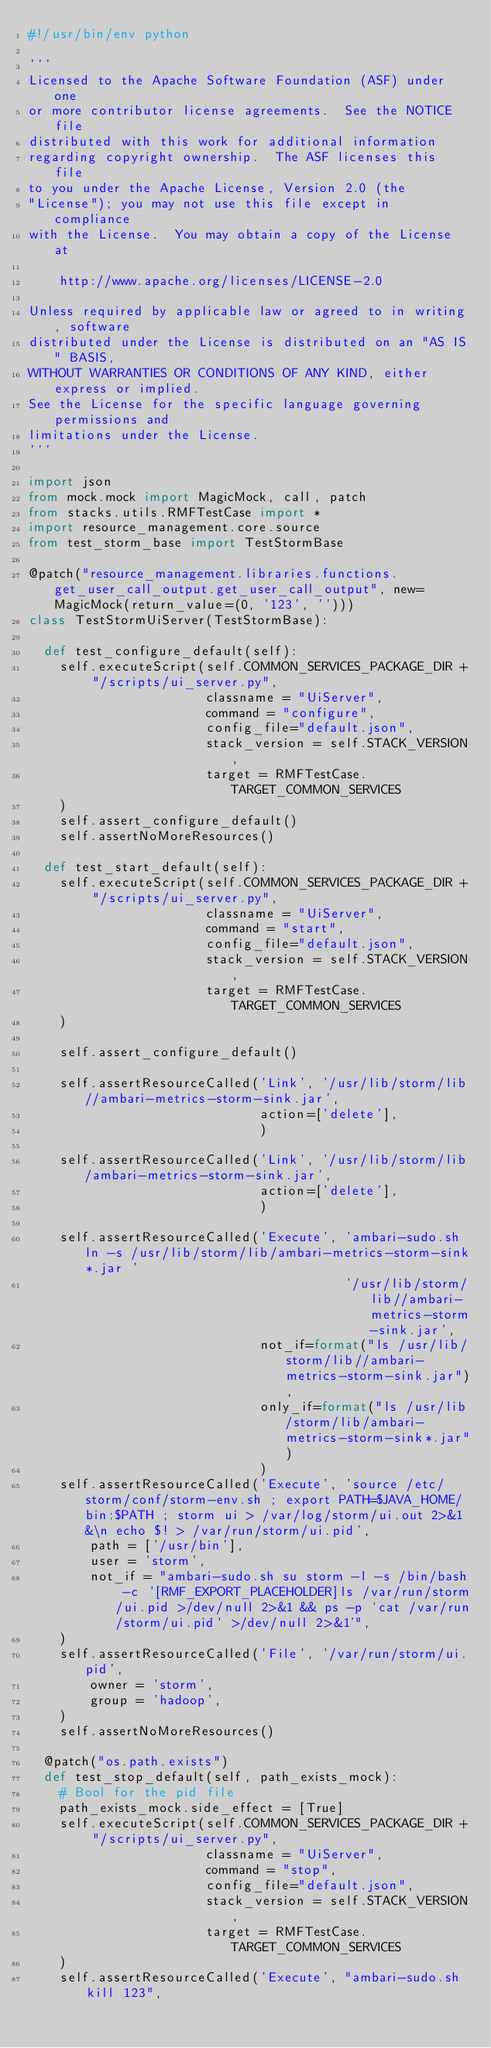Convert code to text. <code><loc_0><loc_0><loc_500><loc_500><_Python_>#!/usr/bin/env python

'''
Licensed to the Apache Software Foundation (ASF) under one
or more contributor license agreements.  See the NOTICE file
distributed with this work for additional information
regarding copyright ownership.  The ASF licenses this file
to you under the Apache License, Version 2.0 (the
"License"); you may not use this file except in compliance
with the License.  You may obtain a copy of the License at

    http://www.apache.org/licenses/LICENSE-2.0

Unless required by applicable law or agreed to in writing, software
distributed under the License is distributed on an "AS IS" BASIS,
WITHOUT WARRANTIES OR CONDITIONS OF ANY KIND, either express or implied.
See the License for the specific language governing permissions and
limitations under the License.
'''

import json
from mock.mock import MagicMock, call, patch
from stacks.utils.RMFTestCase import *
import resource_management.core.source
from test_storm_base import TestStormBase

@patch("resource_management.libraries.functions.get_user_call_output.get_user_call_output", new=MagicMock(return_value=(0, '123', '')))
class TestStormUiServer(TestStormBase):

  def test_configure_default(self):
    self.executeScript(self.COMMON_SERVICES_PACKAGE_DIR + "/scripts/ui_server.py",
                       classname = "UiServer",
                       command = "configure",
                       config_file="default.json",
                       stack_version = self.STACK_VERSION,
                       target = RMFTestCase.TARGET_COMMON_SERVICES
    )
    self.assert_configure_default()
    self.assertNoMoreResources()

  def test_start_default(self):
    self.executeScript(self.COMMON_SERVICES_PACKAGE_DIR + "/scripts/ui_server.py",
                       classname = "UiServer",
                       command = "start",
                       config_file="default.json",
                       stack_version = self.STACK_VERSION,
                       target = RMFTestCase.TARGET_COMMON_SERVICES
    )

    self.assert_configure_default()

    self.assertResourceCalled('Link', '/usr/lib/storm/lib//ambari-metrics-storm-sink.jar',
                              action=['delete'],
                              )

    self.assertResourceCalled('Link', '/usr/lib/storm/lib/ambari-metrics-storm-sink.jar',
                              action=['delete'],
                              )

    self.assertResourceCalled('Execute', 'ambari-sudo.sh ln -s /usr/lib/storm/lib/ambari-metrics-storm-sink*.jar '
                                         '/usr/lib/storm/lib//ambari-metrics-storm-sink.jar',
                              not_if=format("ls /usr/lib/storm/lib//ambari-metrics-storm-sink.jar"),
                              only_if=format("ls /usr/lib/storm/lib/ambari-metrics-storm-sink*.jar")
                              )
    self.assertResourceCalled('Execute', 'source /etc/storm/conf/storm-env.sh ; export PATH=$JAVA_HOME/bin:$PATH ; storm ui > /var/log/storm/ui.out 2>&1 &\n echo $! > /var/run/storm/ui.pid',
        path = ['/usr/bin'],
        user = 'storm',
        not_if = "ambari-sudo.sh su storm -l -s /bin/bash -c '[RMF_EXPORT_PLACEHOLDER]ls /var/run/storm/ui.pid >/dev/null 2>&1 && ps -p `cat /var/run/storm/ui.pid` >/dev/null 2>&1'",
    )
    self.assertResourceCalled('File', '/var/run/storm/ui.pid',
        owner = 'storm',
        group = 'hadoop',
    )
    self.assertNoMoreResources()

  @patch("os.path.exists")
  def test_stop_default(self, path_exists_mock):
    # Bool for the pid file
    path_exists_mock.side_effect = [True]
    self.executeScript(self.COMMON_SERVICES_PACKAGE_DIR + "/scripts/ui_server.py",
                       classname = "UiServer",
                       command = "stop",
                       config_file="default.json",
                       stack_version = self.STACK_VERSION,
                       target = RMFTestCase.TARGET_COMMON_SERVICES
    )
    self.assertResourceCalled('Execute', "ambari-sudo.sh kill 123",</code> 